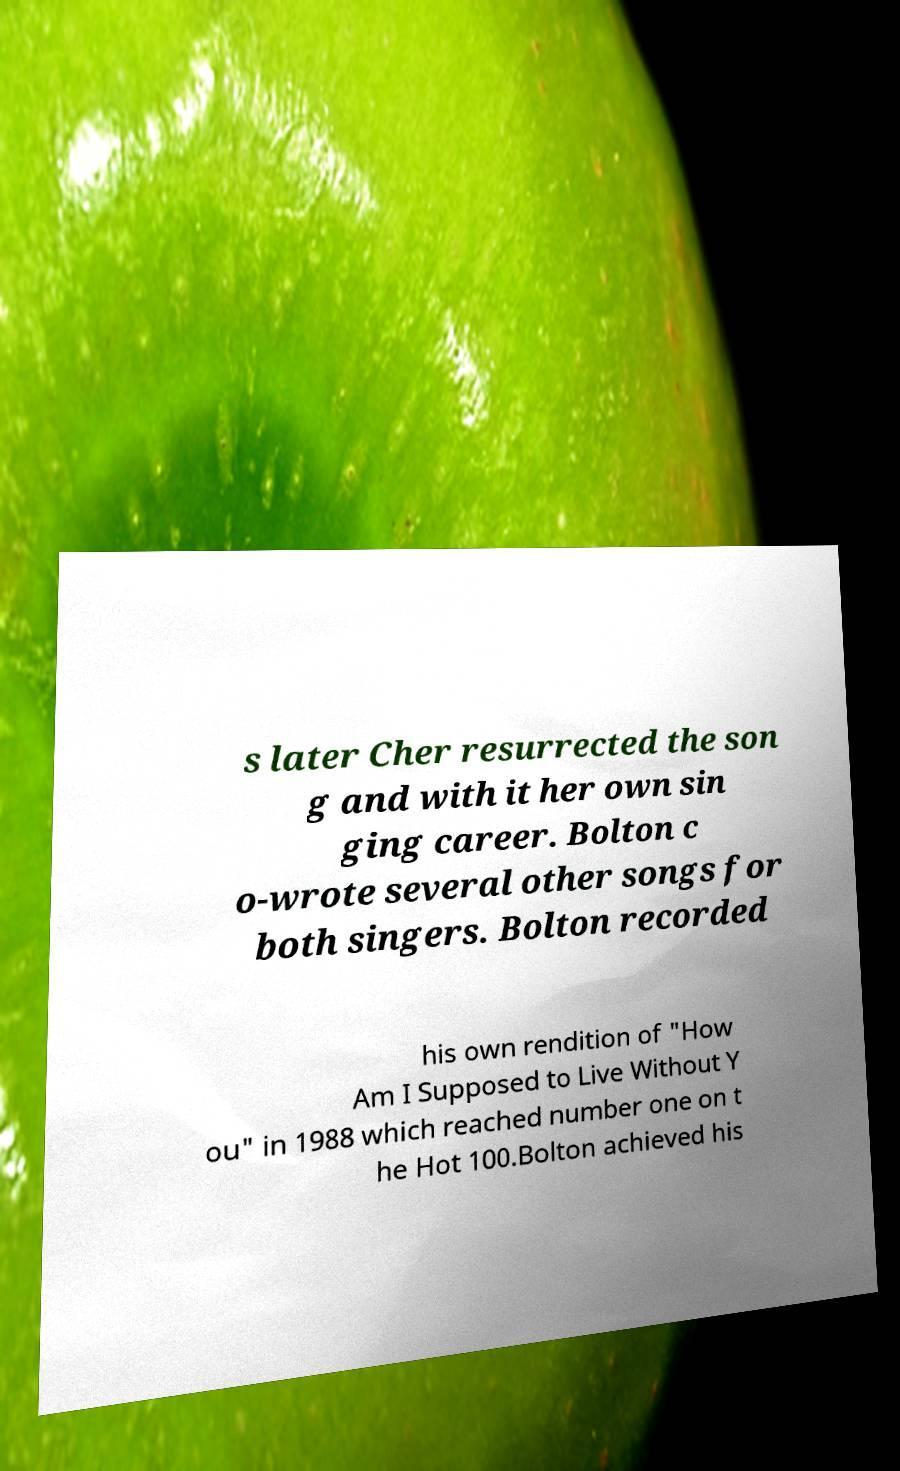There's text embedded in this image that I need extracted. Can you transcribe it verbatim? s later Cher resurrected the son g and with it her own sin ging career. Bolton c o-wrote several other songs for both singers. Bolton recorded his own rendition of "How Am I Supposed to Live Without Y ou" in 1988 which reached number one on t he Hot 100.Bolton achieved his 